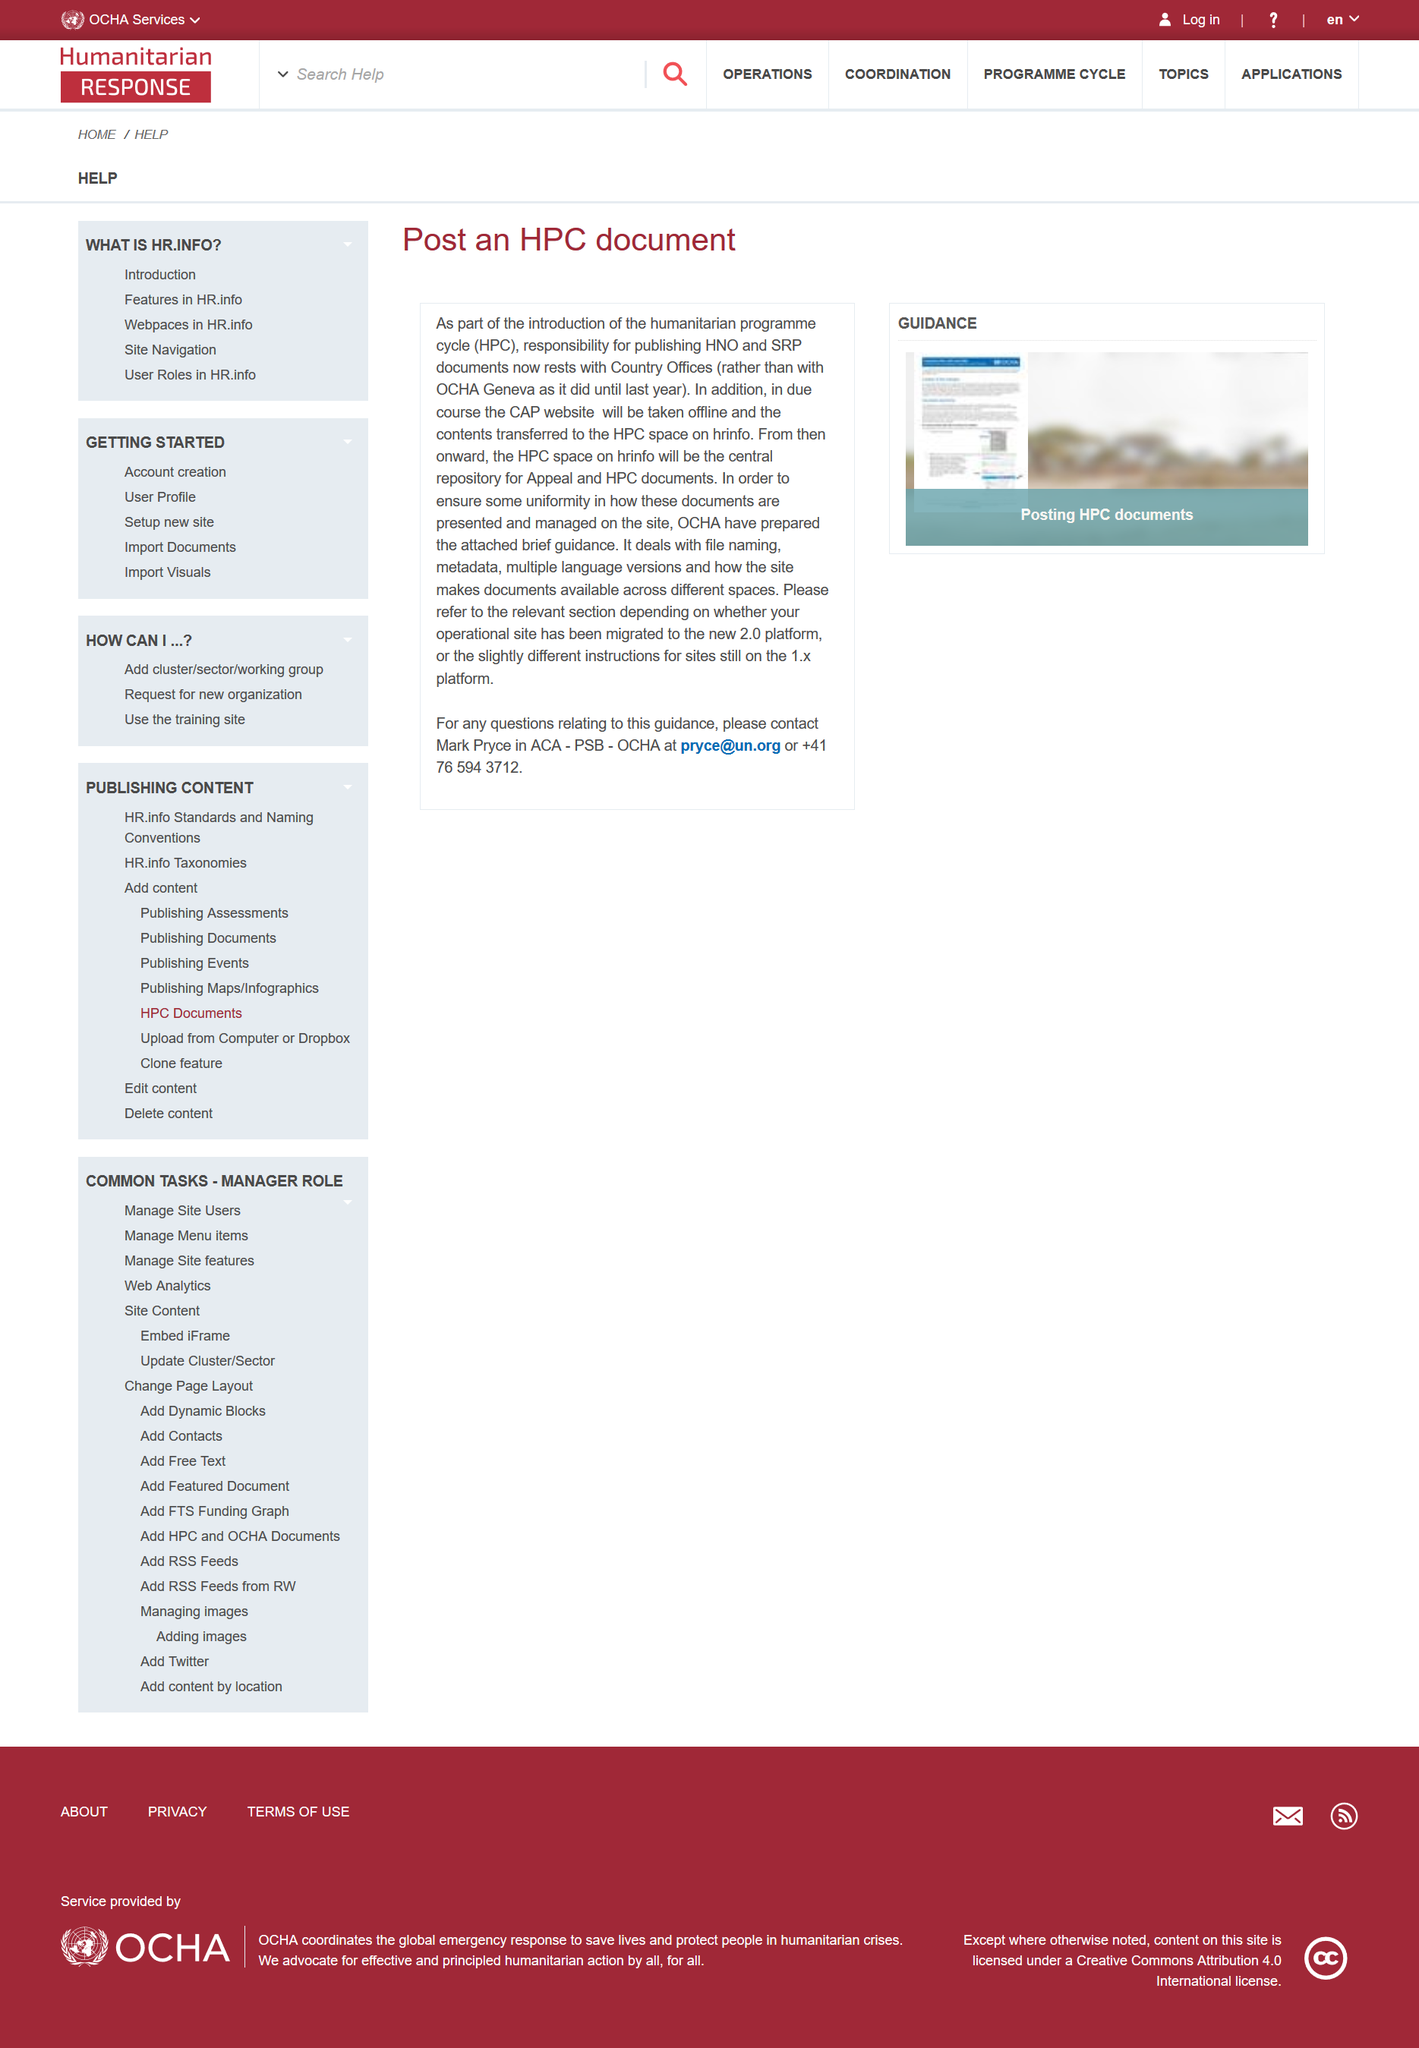Highlight a few significant elements in this photo. The document shown in the picture was prepared by OCHA. The acronym HPC stands for Humanitarian Programme Cycle, which refers to a framework used by the United Nations to manage and coordinate humanitarian assistance and response efforts. This framework consists of four phases: (1) preparedness, (2) response, (3) recovery, and (4) development. The Humanitarian Programme Cycle is designed to ensure a comprehensive and coordinated approach to humanitarian assistance and to help vulnerable populations affected by natural disasters, conflicts, and other crises. Effective immediately, the responsibility for publishing Humanitarian Needs Obligations (HNO) and Service Level Agreements (SLA) documents has been transferred from the Office for the Coordination of Humanitarian Affairs (OCHA) in Geneva to Country Offices. 